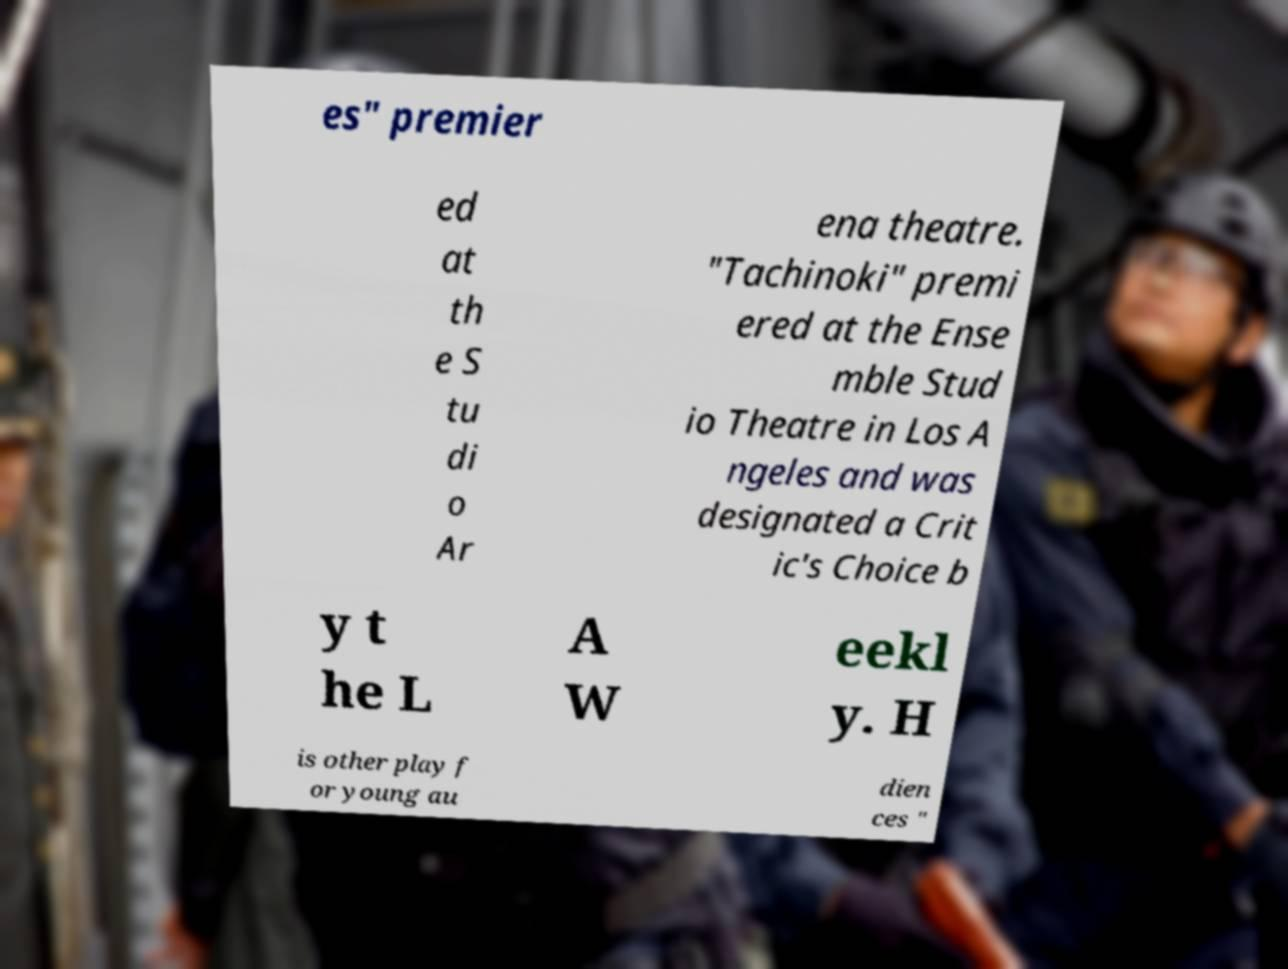Could you extract and type out the text from this image? es" premier ed at th e S tu di o Ar ena theatre. "Tachinoki" premi ered at the Ense mble Stud io Theatre in Los A ngeles and was designated a Crit ic's Choice b y t he L A W eekl y. H is other play f or young au dien ces " 